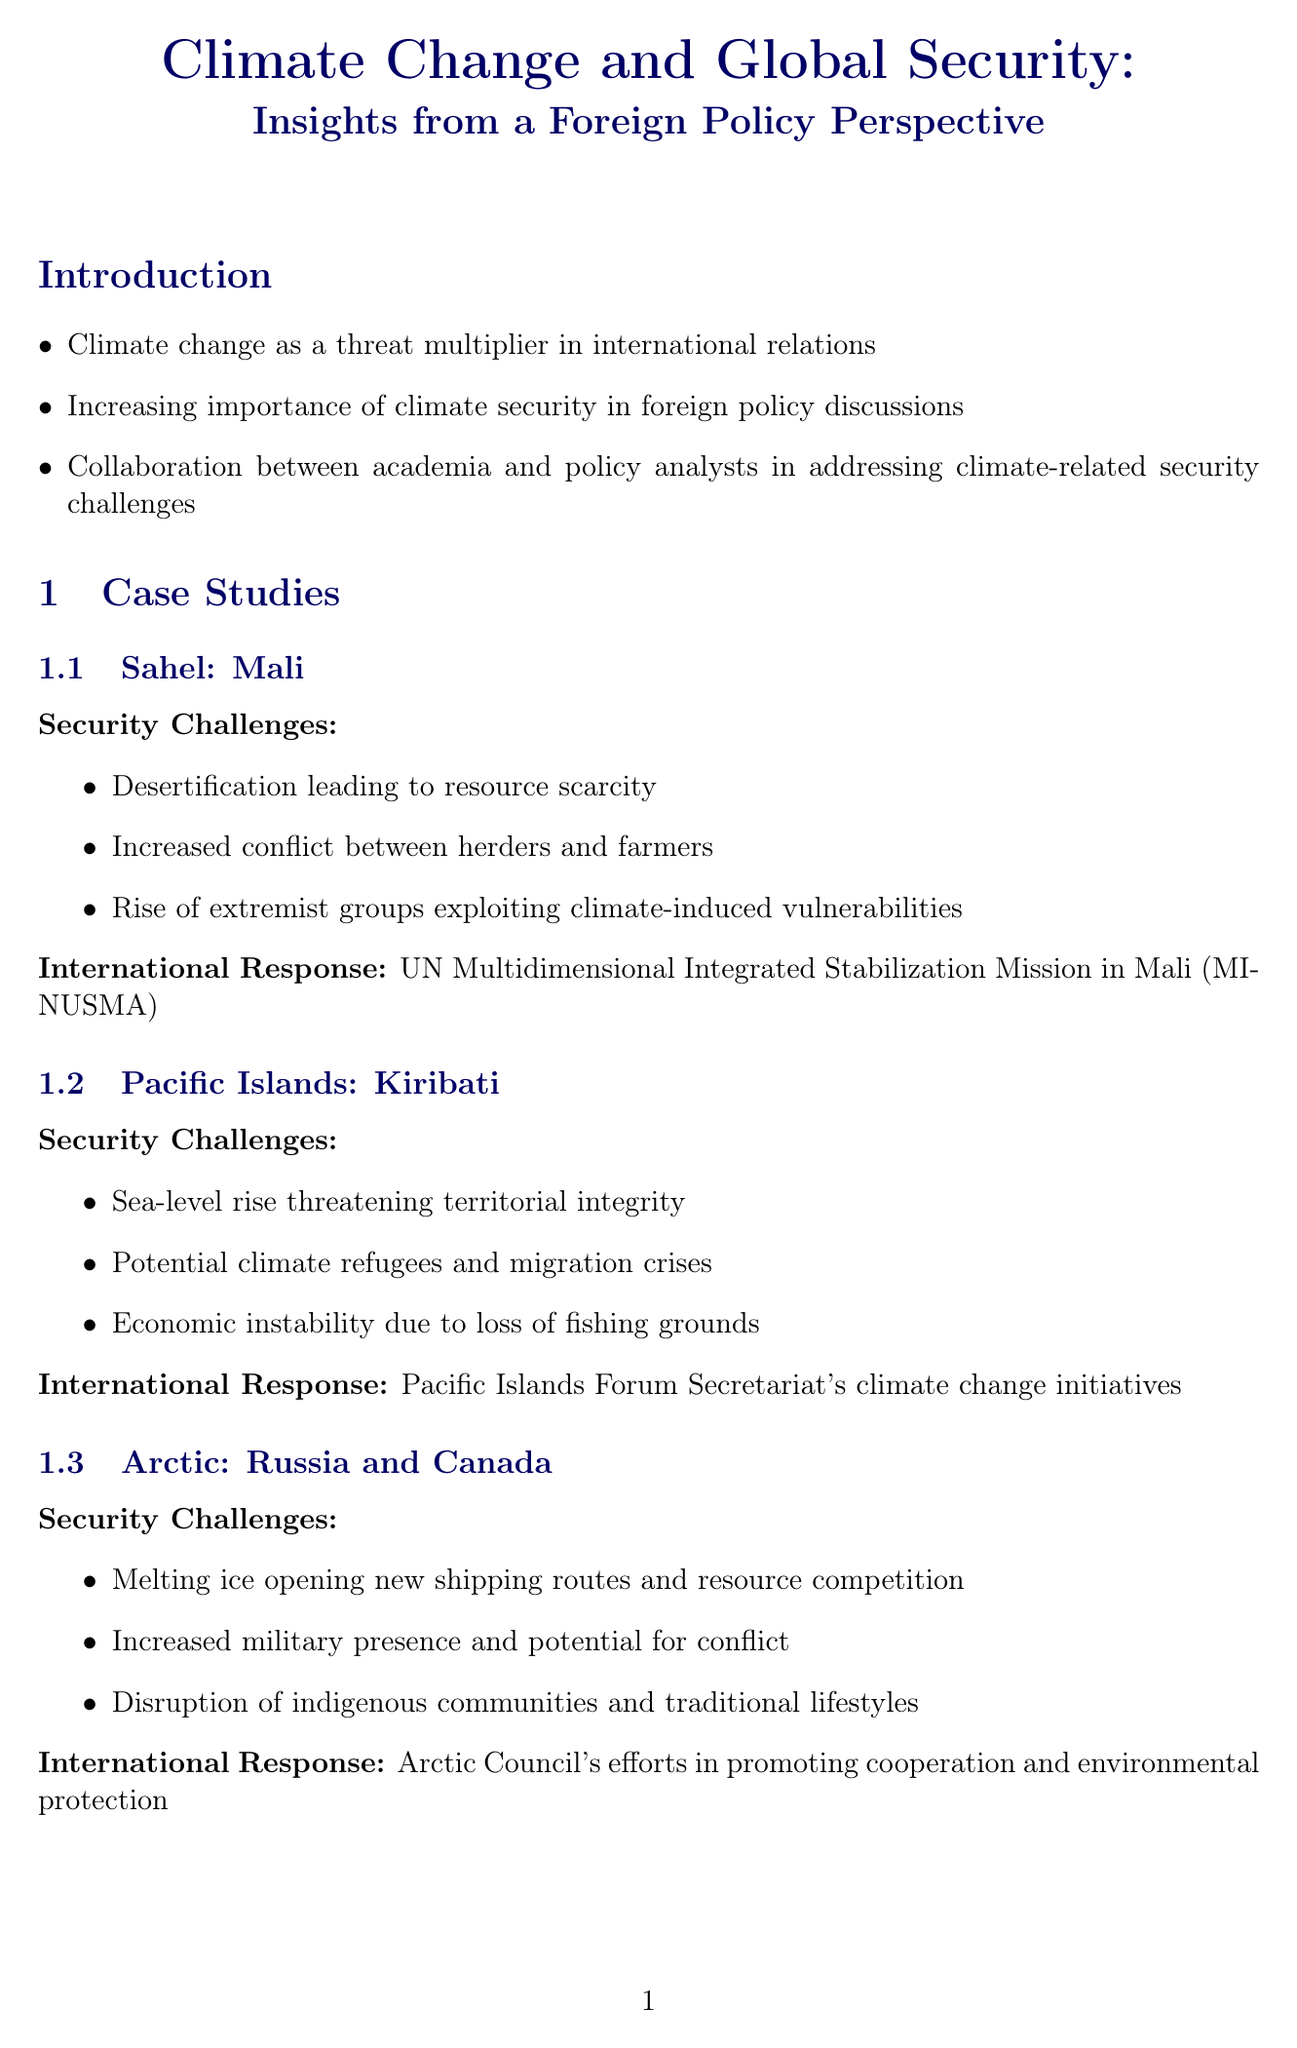What is the title of the newsletter? The title is explicitly stated at the beginning of the document.
Answer: Climate Change and Global Security: Insights from a Foreign Policy Perspective Which region is specifically focused on within the case study of Mali? The region is highlighted in the section pertaining to the specific case study about Mali.
Answer: Sahel What is the main international response noted for the Pacific Islands case study? The international response is detailed alongside the challenges faced in the case study for Kiribati.
Answer: Pacific Islands Forum Secretariat's climate change initiatives Who is the expert quoted in the document? The expert's name is given in the section that presents an opinion by a recognized authority in the field.
Answer: Dr. Amelia Rodríguez What date does COP28 take place? The date is mentioned in the upcoming events section of the document.
Answer: November 30 - December 12, 2023 What type of climate challenge is highlighted in the Arctic case study? The specific challenge is listed as part of the security challenges faced in the Arctic region.
Answer: Melting ice opening new shipping routes and resource competition Which policy recommendation focuses on early warning systems? The focus area of the recommendation is stated in the section related to policy suggestions.
Answer: Conflict Prevention How many case studies are presented in the document? The number of case studies is derived from listing the cases mentioned in the respective section.
Answer: Three What organization is responsible for integrating climate factors into national security strategies? The implementing body for the recommendation is specified in the policy recommendations section.
Answer: U.S. Department of State and National Security Council 